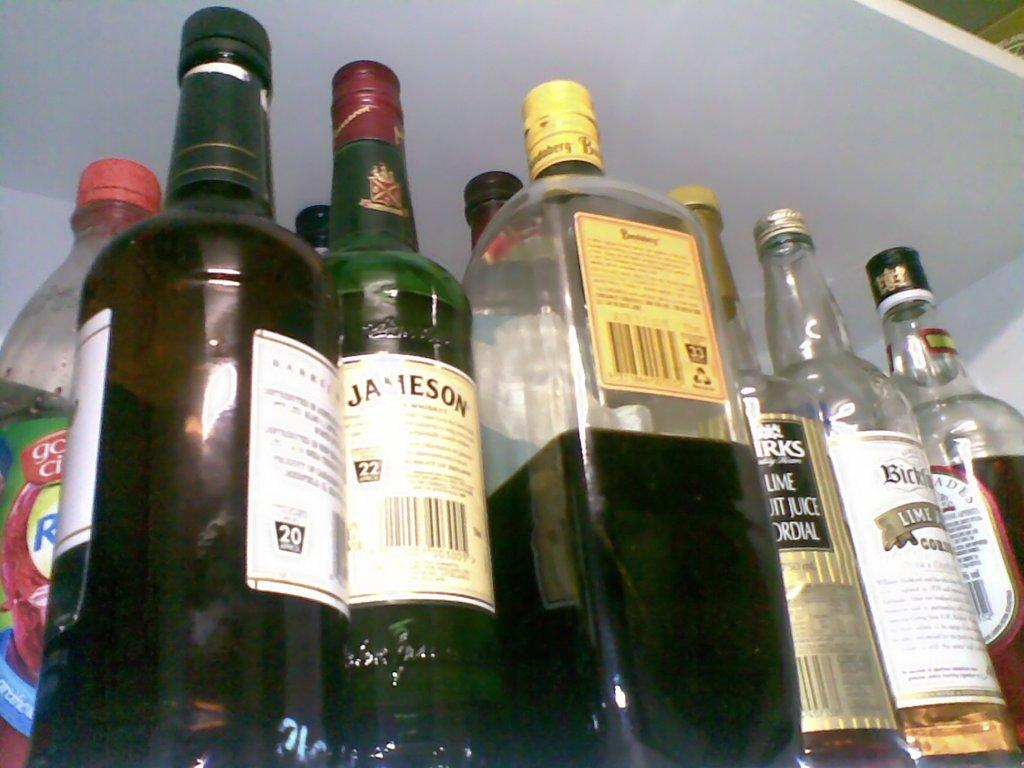Provide a one-sentence caption for the provided image. A bottle of Jameson is surrounded by six other bottles of various liquors. 